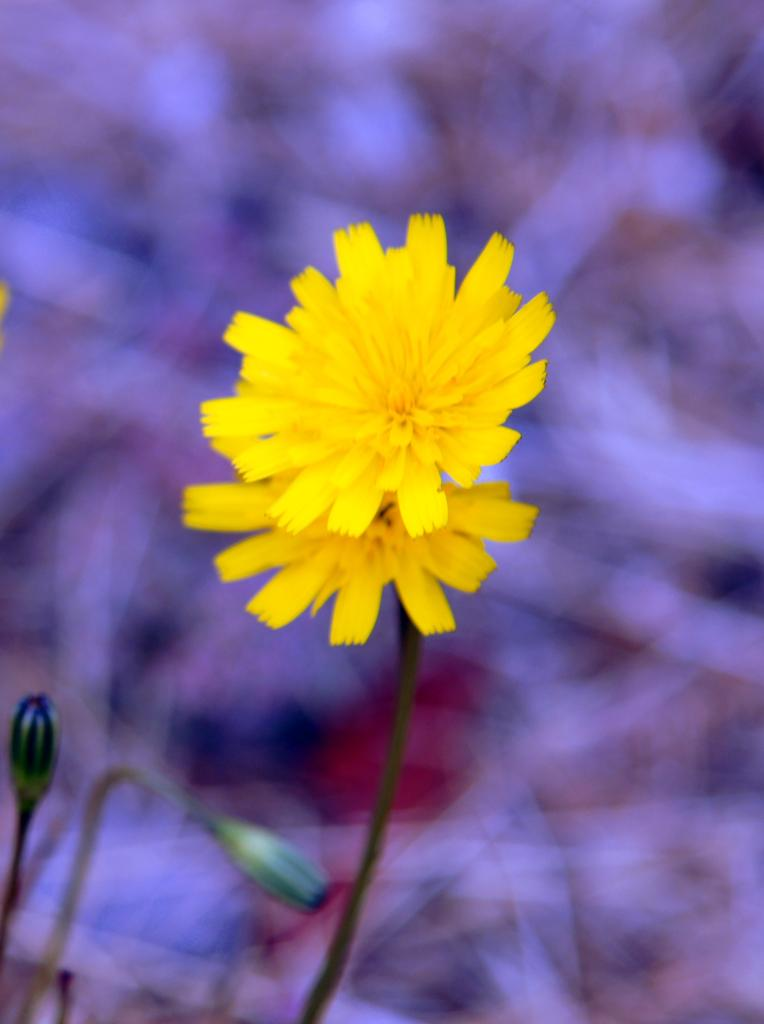What type of plants can be seen in the image? There are flowers in the image. Can you describe the stage of growth for some of the plants in the image? Yes, there are buds in the image, which are flowers in the early stages of development. What type of milk can be seen in the image? There is no milk present in the image; it features flowers and buds. Can you hear the voice of the flowers in the image? Flowers do not have the ability to produce or convey voice, so there is no voice present in the image. 